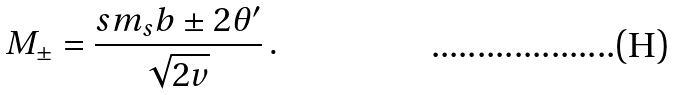Convert formula to latex. <formula><loc_0><loc_0><loc_500><loc_500>M _ { \pm } = \frac { s m _ { s } b \pm 2 \theta ^ { \prime } } { \sqrt { 2 v } } \, .</formula> 